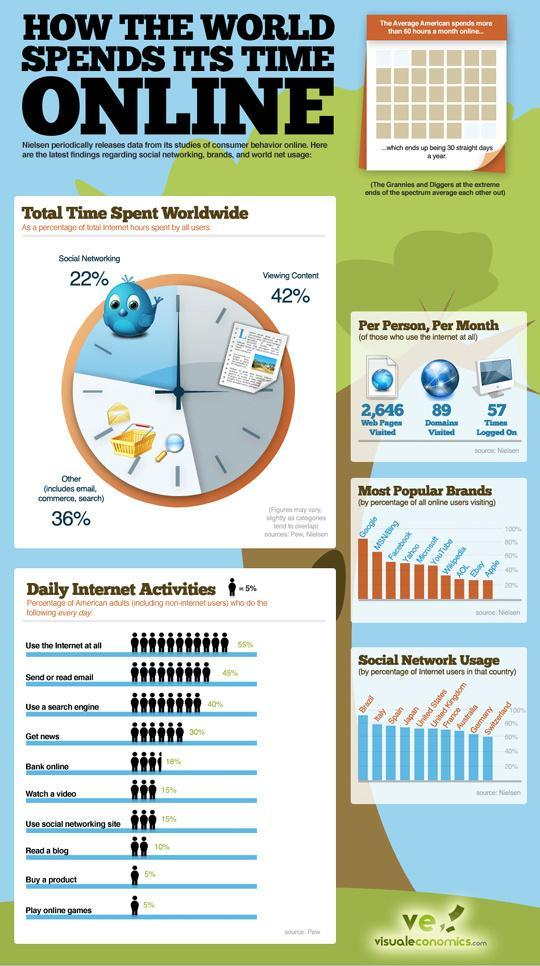What percentage of the American adults send or read email everyday?
Answer the question with a short phrase. 45% Which country has above 80% of the internet users among the selected countries? Brazil How many web pages are visited by each person per month worldwide? 2,646 What percentage of internet users worldwide spend time viewing content? 42% What percentage of internet users spend time on social networking across the world? 22% What percentage of the American adults do online banking everyday? 18% What percentage of the American adults play online games everyday? 5% 